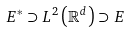Convert formula to latex. <formula><loc_0><loc_0><loc_500><loc_500>E ^ { \ast } \supset L ^ { 2 } \left ( \mathbb { R } ^ { d } \right ) \supset E</formula> 